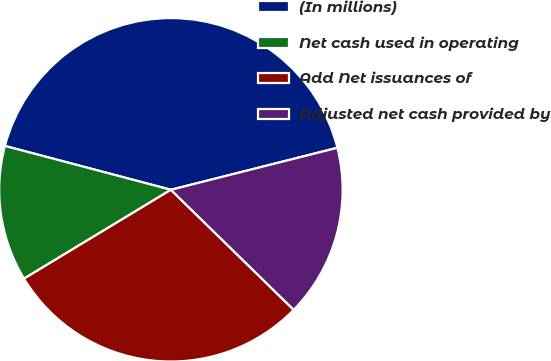Convert chart. <chart><loc_0><loc_0><loc_500><loc_500><pie_chart><fcel>(In millions)<fcel>Net cash used in operating<fcel>Add Net issuances of<fcel>Adjusted net cash provided by<nl><fcel>41.95%<fcel>12.77%<fcel>29.02%<fcel>16.25%<nl></chart> 